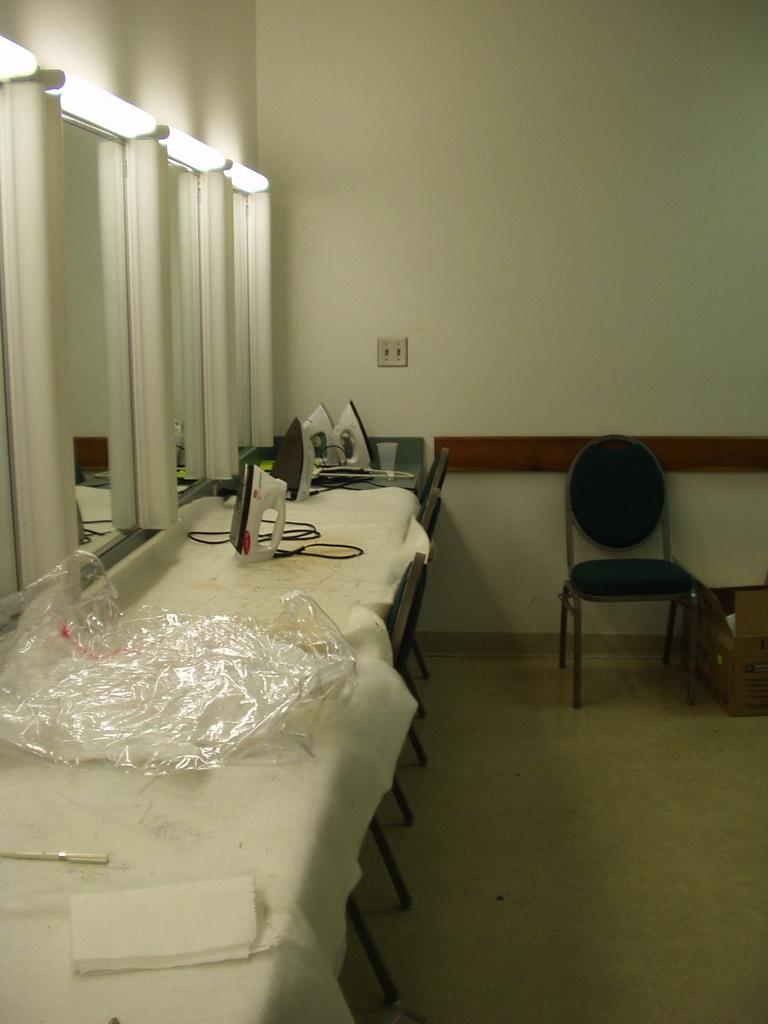What objects are present in the image that reflect light? There are mirrors in the image. What is located above the mirrors? There are lumps above the mirrors. What type of containers are on a platform below the mirrors? There are iron boxes on a platform below the mirrors. What is in front of the iron boxes? There is a chair in front of the iron boxes. Can you hear a bell ringing in the image? There is no bell present in the image, so it cannot be heard ringing. 